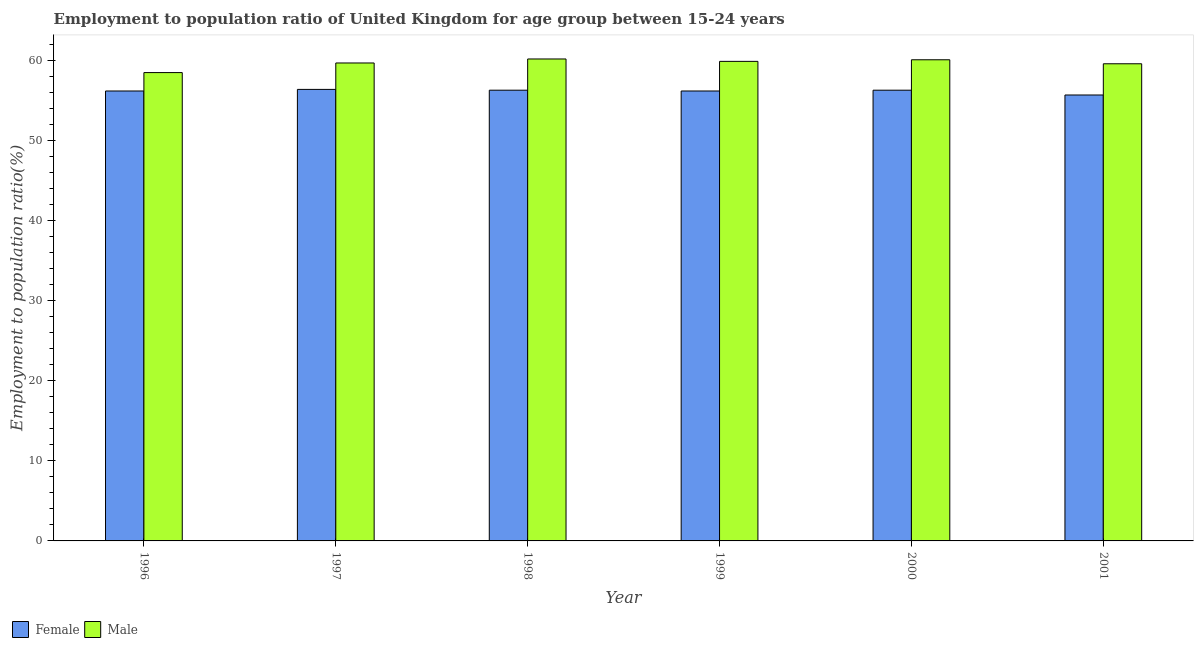How many different coloured bars are there?
Provide a short and direct response. 2. Are the number of bars per tick equal to the number of legend labels?
Provide a succinct answer. Yes. Are the number of bars on each tick of the X-axis equal?
Your response must be concise. Yes. How many bars are there on the 1st tick from the left?
Keep it short and to the point. 2. What is the label of the 5th group of bars from the left?
Offer a terse response. 2000. What is the employment to population ratio(male) in 1997?
Offer a terse response. 59.7. Across all years, what is the maximum employment to population ratio(female)?
Offer a terse response. 56.4. Across all years, what is the minimum employment to population ratio(male)?
Your answer should be compact. 58.5. In which year was the employment to population ratio(male) maximum?
Offer a very short reply. 1998. In which year was the employment to population ratio(male) minimum?
Keep it short and to the point. 1996. What is the total employment to population ratio(female) in the graph?
Provide a succinct answer. 337.1. What is the difference between the employment to population ratio(female) in 1996 and that in 1998?
Your answer should be compact. -0.1. What is the difference between the employment to population ratio(male) in 1998 and the employment to population ratio(female) in 2000?
Your answer should be compact. 0.1. What is the average employment to population ratio(female) per year?
Your answer should be compact. 56.18. In the year 2000, what is the difference between the employment to population ratio(male) and employment to population ratio(female)?
Provide a short and direct response. 0. What is the ratio of the employment to population ratio(male) in 1997 to that in 1999?
Your answer should be very brief. 1. Is the employment to population ratio(male) in 1997 less than that in 1998?
Ensure brevity in your answer.  Yes. Is the difference between the employment to population ratio(male) in 1998 and 2001 greater than the difference between the employment to population ratio(female) in 1998 and 2001?
Provide a short and direct response. No. What is the difference between the highest and the second highest employment to population ratio(female)?
Make the answer very short. 0.1. What is the difference between the highest and the lowest employment to population ratio(female)?
Give a very brief answer. 0.7. In how many years, is the employment to population ratio(female) greater than the average employment to population ratio(female) taken over all years?
Give a very brief answer. 5. What does the 1st bar from the left in 1996 represents?
Ensure brevity in your answer.  Female. How many bars are there?
Give a very brief answer. 12. How many years are there in the graph?
Provide a short and direct response. 6. What is the difference between two consecutive major ticks on the Y-axis?
Give a very brief answer. 10. Where does the legend appear in the graph?
Give a very brief answer. Bottom left. How many legend labels are there?
Offer a very short reply. 2. What is the title of the graph?
Offer a terse response. Employment to population ratio of United Kingdom for age group between 15-24 years. What is the Employment to population ratio(%) of Female in 1996?
Your answer should be very brief. 56.2. What is the Employment to population ratio(%) of Male in 1996?
Keep it short and to the point. 58.5. What is the Employment to population ratio(%) in Female in 1997?
Your response must be concise. 56.4. What is the Employment to population ratio(%) in Male in 1997?
Give a very brief answer. 59.7. What is the Employment to population ratio(%) in Female in 1998?
Your answer should be compact. 56.3. What is the Employment to population ratio(%) in Male in 1998?
Your answer should be very brief. 60.2. What is the Employment to population ratio(%) in Female in 1999?
Ensure brevity in your answer.  56.2. What is the Employment to population ratio(%) of Male in 1999?
Your response must be concise. 59.9. What is the Employment to population ratio(%) in Female in 2000?
Ensure brevity in your answer.  56.3. What is the Employment to population ratio(%) of Male in 2000?
Make the answer very short. 60.1. What is the Employment to population ratio(%) in Female in 2001?
Provide a short and direct response. 55.7. What is the Employment to population ratio(%) of Male in 2001?
Provide a short and direct response. 59.6. Across all years, what is the maximum Employment to population ratio(%) in Female?
Offer a very short reply. 56.4. Across all years, what is the maximum Employment to population ratio(%) of Male?
Provide a succinct answer. 60.2. Across all years, what is the minimum Employment to population ratio(%) in Female?
Provide a short and direct response. 55.7. Across all years, what is the minimum Employment to population ratio(%) in Male?
Give a very brief answer. 58.5. What is the total Employment to population ratio(%) in Female in the graph?
Your answer should be very brief. 337.1. What is the total Employment to population ratio(%) of Male in the graph?
Offer a very short reply. 358. What is the difference between the Employment to population ratio(%) of Female in 1996 and that in 1997?
Provide a short and direct response. -0.2. What is the difference between the Employment to population ratio(%) of Female in 1996 and that in 1998?
Offer a terse response. -0.1. What is the difference between the Employment to population ratio(%) of Male in 1996 and that in 1998?
Provide a short and direct response. -1.7. What is the difference between the Employment to population ratio(%) of Male in 1996 and that in 1999?
Keep it short and to the point. -1.4. What is the difference between the Employment to population ratio(%) of Female in 1996 and that in 2001?
Your answer should be very brief. 0.5. What is the difference between the Employment to population ratio(%) in Female in 1997 and that in 1998?
Make the answer very short. 0.1. What is the difference between the Employment to population ratio(%) in Female in 1997 and that in 1999?
Make the answer very short. 0.2. What is the difference between the Employment to population ratio(%) of Male in 1997 and that in 1999?
Offer a terse response. -0.2. What is the difference between the Employment to population ratio(%) of Female in 1997 and that in 2000?
Ensure brevity in your answer.  0.1. What is the difference between the Employment to population ratio(%) in Male in 1997 and that in 2001?
Your response must be concise. 0.1. What is the difference between the Employment to population ratio(%) in Male in 1998 and that in 1999?
Keep it short and to the point. 0.3. What is the difference between the Employment to population ratio(%) of Female in 1998 and that in 2000?
Provide a succinct answer. 0. What is the difference between the Employment to population ratio(%) in Male in 1998 and that in 2000?
Offer a very short reply. 0.1. What is the difference between the Employment to population ratio(%) of Male in 1999 and that in 2000?
Offer a very short reply. -0.2. What is the difference between the Employment to population ratio(%) of Female in 1996 and the Employment to population ratio(%) of Male in 1997?
Your response must be concise. -3.5. What is the difference between the Employment to population ratio(%) in Female in 1996 and the Employment to population ratio(%) in Male in 1998?
Offer a very short reply. -4. What is the difference between the Employment to population ratio(%) of Female in 1996 and the Employment to population ratio(%) of Male in 1999?
Offer a terse response. -3.7. What is the difference between the Employment to population ratio(%) of Female in 1997 and the Employment to population ratio(%) of Male in 1998?
Offer a very short reply. -3.8. What is the difference between the Employment to population ratio(%) in Female in 1997 and the Employment to population ratio(%) in Male in 2001?
Keep it short and to the point. -3.2. What is the difference between the Employment to population ratio(%) of Female in 1998 and the Employment to population ratio(%) of Male in 1999?
Make the answer very short. -3.6. What is the difference between the Employment to population ratio(%) in Female in 1998 and the Employment to population ratio(%) in Male in 2001?
Provide a short and direct response. -3.3. What is the difference between the Employment to population ratio(%) in Female in 1999 and the Employment to population ratio(%) in Male in 2000?
Your answer should be compact. -3.9. What is the difference between the Employment to population ratio(%) in Female in 2000 and the Employment to population ratio(%) in Male in 2001?
Keep it short and to the point. -3.3. What is the average Employment to population ratio(%) of Female per year?
Ensure brevity in your answer.  56.18. What is the average Employment to population ratio(%) in Male per year?
Ensure brevity in your answer.  59.67. In the year 1996, what is the difference between the Employment to population ratio(%) in Female and Employment to population ratio(%) in Male?
Your answer should be compact. -2.3. In the year 1998, what is the difference between the Employment to population ratio(%) in Female and Employment to population ratio(%) in Male?
Provide a short and direct response. -3.9. What is the ratio of the Employment to population ratio(%) in Female in 1996 to that in 1997?
Your response must be concise. 1. What is the ratio of the Employment to population ratio(%) in Male in 1996 to that in 1997?
Make the answer very short. 0.98. What is the ratio of the Employment to population ratio(%) in Male in 1996 to that in 1998?
Offer a terse response. 0.97. What is the ratio of the Employment to population ratio(%) in Female in 1996 to that in 1999?
Your response must be concise. 1. What is the ratio of the Employment to population ratio(%) of Male in 1996 to that in 1999?
Your answer should be very brief. 0.98. What is the ratio of the Employment to population ratio(%) in Female in 1996 to that in 2000?
Your response must be concise. 1. What is the ratio of the Employment to population ratio(%) in Male in 1996 to that in 2000?
Keep it short and to the point. 0.97. What is the ratio of the Employment to population ratio(%) of Male in 1996 to that in 2001?
Your answer should be very brief. 0.98. What is the ratio of the Employment to population ratio(%) of Male in 1997 to that in 1998?
Your answer should be compact. 0.99. What is the ratio of the Employment to population ratio(%) of Female in 1997 to that in 2001?
Ensure brevity in your answer.  1.01. What is the ratio of the Employment to population ratio(%) in Male in 1997 to that in 2001?
Ensure brevity in your answer.  1. What is the ratio of the Employment to population ratio(%) of Female in 1998 to that in 2000?
Keep it short and to the point. 1. What is the ratio of the Employment to population ratio(%) of Female in 1998 to that in 2001?
Make the answer very short. 1.01. What is the ratio of the Employment to population ratio(%) in Female in 2000 to that in 2001?
Your response must be concise. 1.01. What is the ratio of the Employment to population ratio(%) in Male in 2000 to that in 2001?
Provide a short and direct response. 1.01. What is the difference between the highest and the second highest Employment to population ratio(%) in Male?
Offer a terse response. 0.1. What is the difference between the highest and the lowest Employment to population ratio(%) in Female?
Make the answer very short. 0.7. What is the difference between the highest and the lowest Employment to population ratio(%) in Male?
Your answer should be compact. 1.7. 